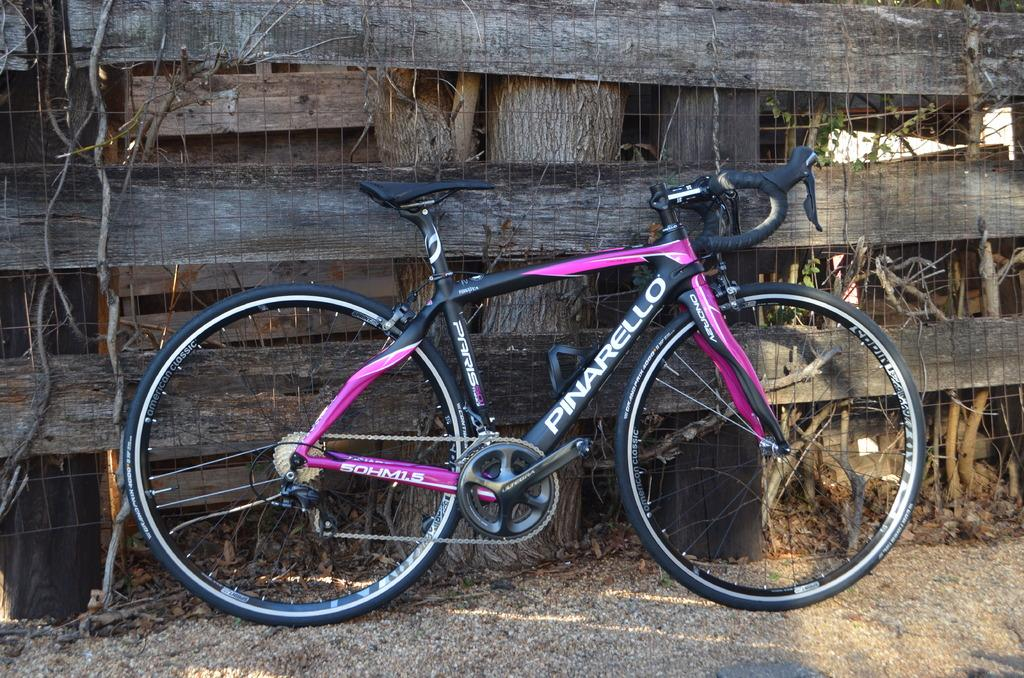What is the main object in the image? There is a bicycle in the image. What can be seen beneath the bicycle? The ground is visible in the image. What type of barrier is present in the image? There is a fence in the image. What type of vegetation is present in the image? Tree trunks and plants are present in the image. What part of the plants can be seen in the image? Roots are visible in the image. What type of mass is being tested in the image? There is no indication of a mass or any testing being conducted in the image. 